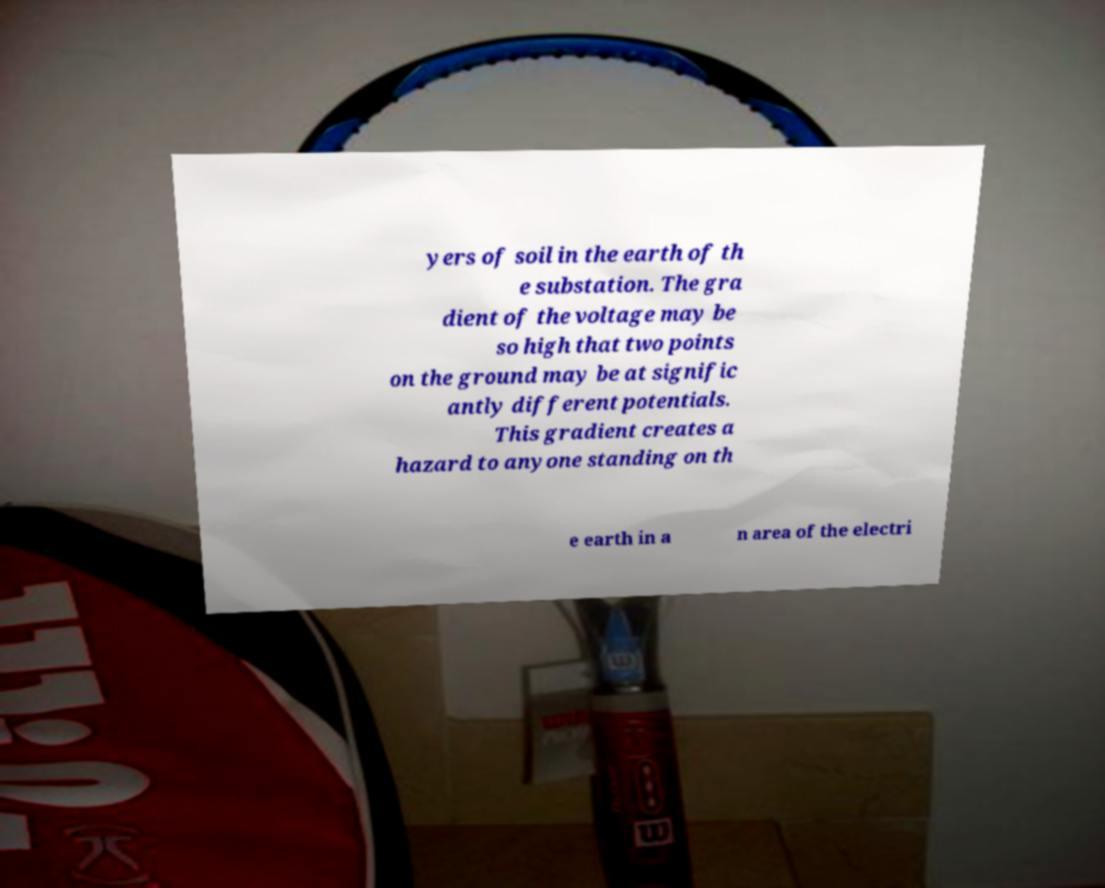Please read and relay the text visible in this image. What does it say? yers of soil in the earth of th e substation. The gra dient of the voltage may be so high that two points on the ground may be at signific antly different potentials. This gradient creates a hazard to anyone standing on th e earth in a n area of the electri 